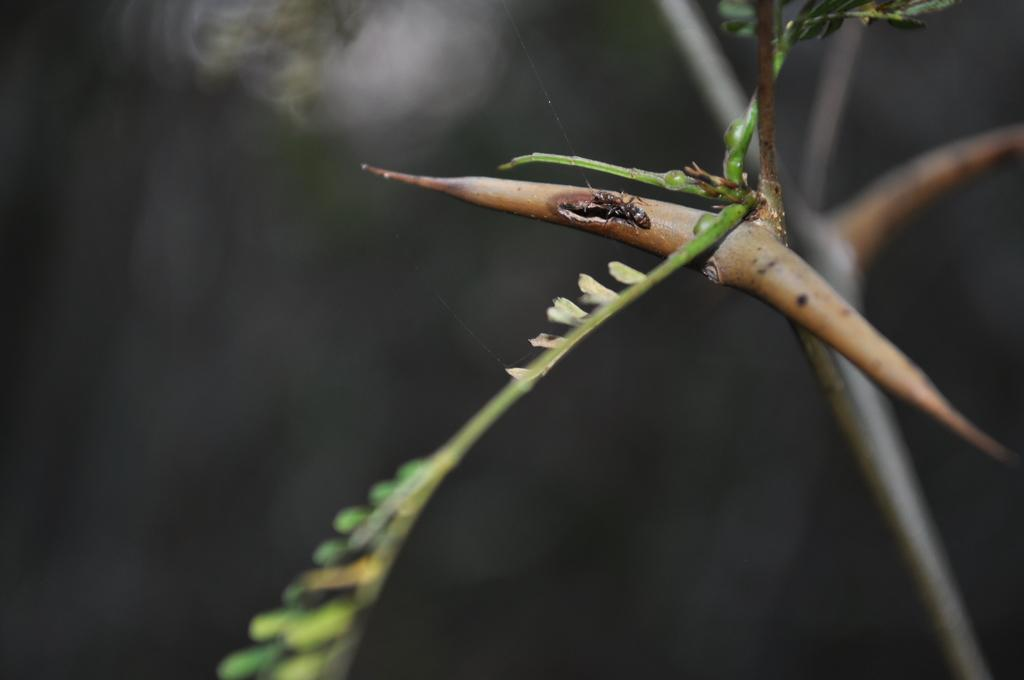What is present on the plant in the image? There is an insect on a plant in the image. How would you describe the background of the image? The background of the image is blurred. Can you describe the overall lighting in the image? The image is dark. What type of jelly is being used to make the insect stick to the plant in the image? There is no jelly present in the image, and the insect is naturally on the plant. How does the image change when viewed from a different angle? The image does not change when viewed from a different angle, as it is a still image. 